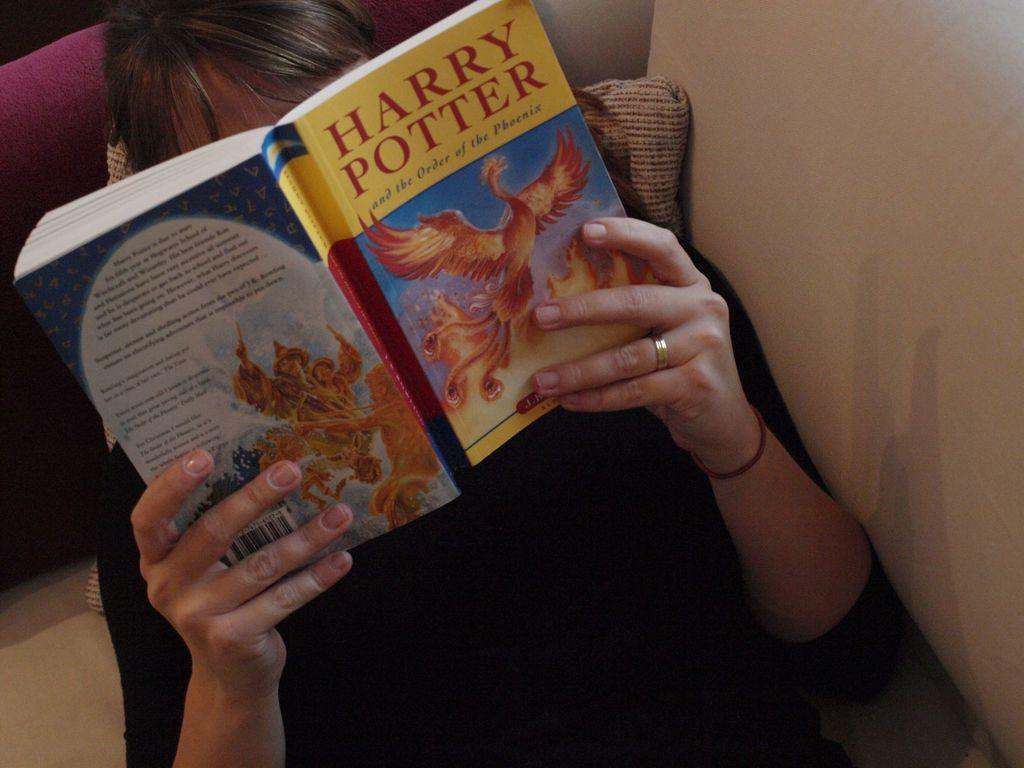Provide a one-sentence caption for the provided image. A person laying on a sofa and reading a paperback version of "Harry Potter and the Order of the Phoenix". 